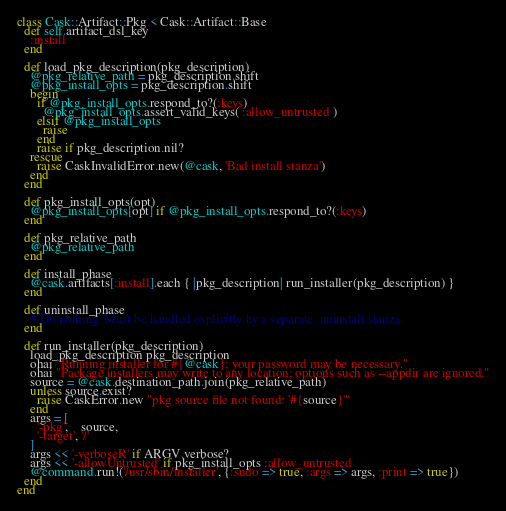<code> <loc_0><loc_0><loc_500><loc_500><_Ruby_>class Cask::Artifact::Pkg < Cask::Artifact::Base
  def self.artifact_dsl_key
    :install
  end

  def load_pkg_description(pkg_description)
    @pkg_relative_path = pkg_description.shift
    @pkg_install_opts = pkg_description.shift
    begin
      if @pkg_install_opts.respond_to?(:keys)
        @pkg_install_opts.assert_valid_keys( :allow_untrusted )
      elsif @pkg_install_opts
        raise
      end
      raise if pkg_description.nil?
    rescue
      raise CaskInvalidError.new(@cask, 'Bad install stanza')
    end
  end

  def pkg_install_opts(opt)
    @pkg_install_opts[opt] if @pkg_install_opts.respond_to?(:keys)
  end

  def pkg_relative_path
    @pkg_relative_path
  end

  def install_phase
    @cask.artifacts[:install].each { |pkg_description| run_installer(pkg_description) }
  end

  def uninstall_phase
    # Do nothing. Must be handled explicitly by a separate :uninstall stanza.
  end

  def run_installer(pkg_description)
    load_pkg_description pkg_description
    ohai "Running installer for #{@cask}; your password may be necessary."
    ohai "Package installers may write to any location; options such as --appdir are ignored."
    source = @cask.destination_path.join(pkg_relative_path)
    unless source.exist?
      raise CaskError.new "pkg source file not found: '#{source}'"
    end
    args = [
      '-pkg',    source,
      '-target', '/'
    ]
    args << '-verboseR' if ARGV.verbose?
    args << '-allowUntrusted' if pkg_install_opts :allow_untrusted
    @command.run!('/usr/sbin/installer', {:sudo => true, :args => args, :print => true})
  end
end
</code> 